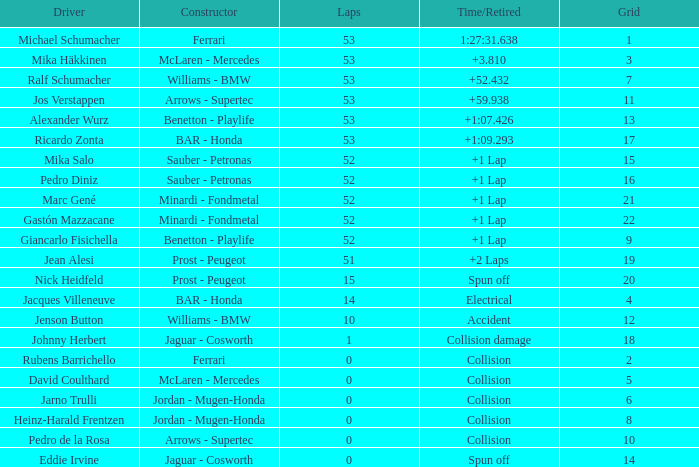How many rounds did ricardo zonta finish? 53.0. 